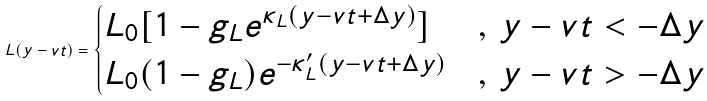Convert formula to latex. <formula><loc_0><loc_0><loc_500><loc_500>L ( y - v t ) = \begin{cases} L _ { 0 } [ 1 - g _ { L } e ^ { \kappa _ { L } ( y - v t + \Delta y ) } ] & , \, y - v t < - \Delta y \\ L _ { 0 } ( 1 - g _ { L } ) e ^ { - \kappa ^ { \prime } _ { L } ( y - v t + \Delta y ) } & , \, y - v t > - \Delta y \end{cases}</formula> 